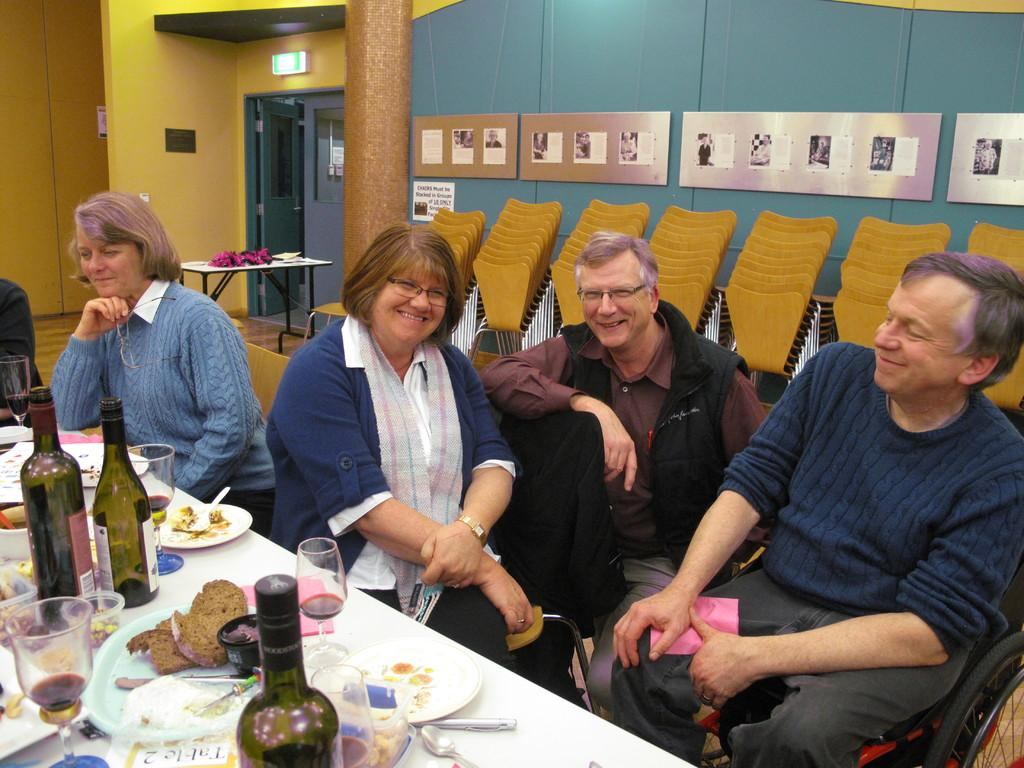What color is the wall in the image? The wall in the image is yellow. What can be found on the wall? There is a door in the image. What furniture is present in the image? There is a table in the image. What are the people in the image doing? There are people sitting on chairs in the image. What items can be seen on the table? There are plates, spoons, bottles, and bowls on the table. What type of scarf is draped over the chair in the image? There is no scarf present in the image. What is the mindset of the people sitting on the chairs in the image? The image does not provide information about the mindset of the people sitting on the chairs. 